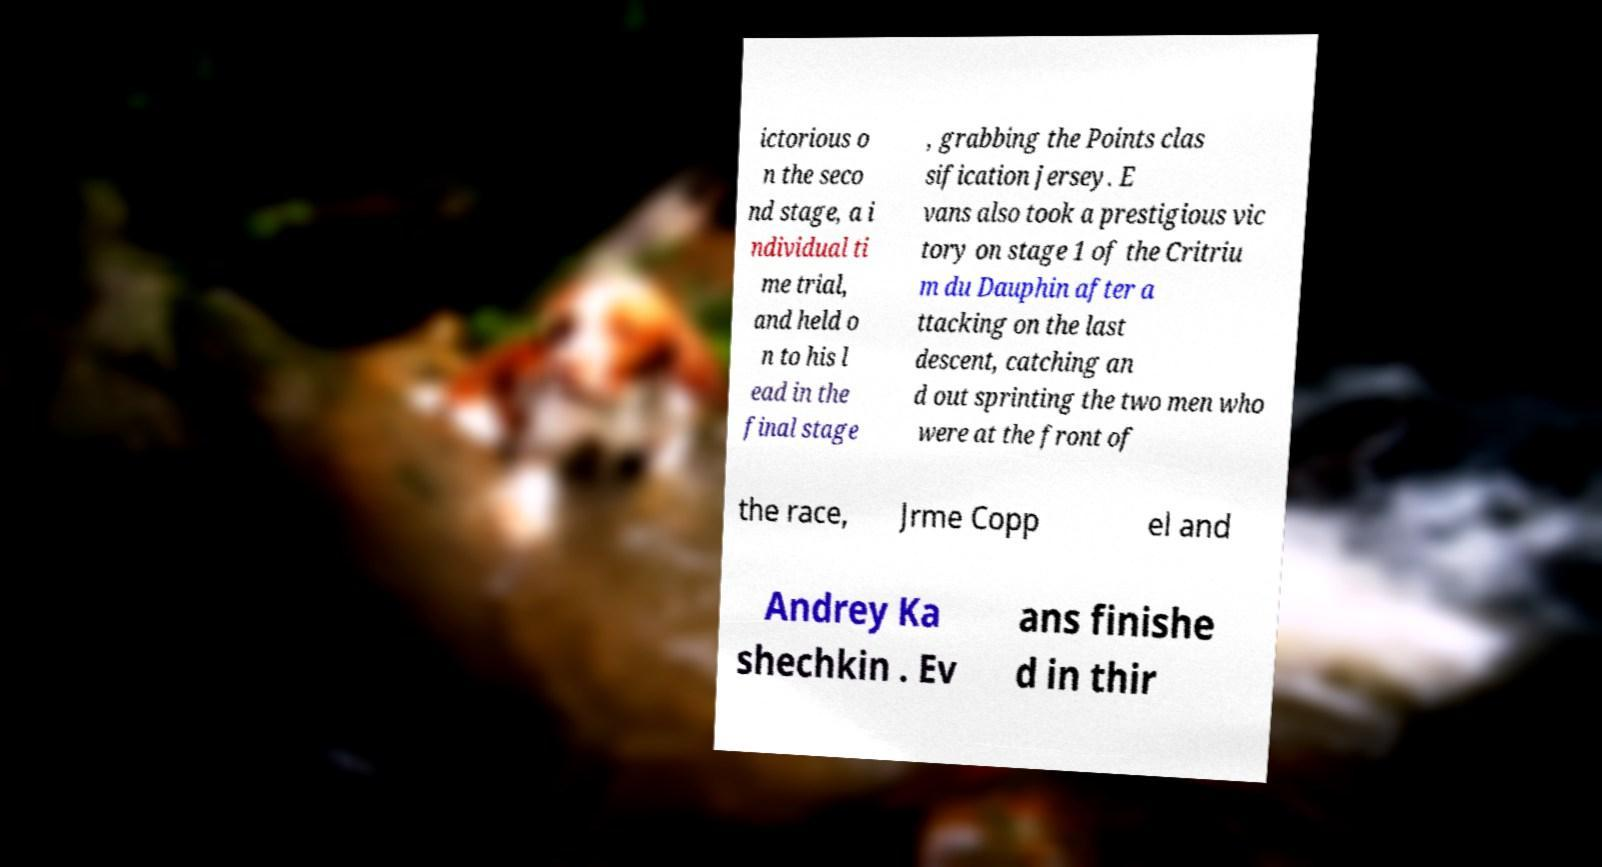Could you assist in decoding the text presented in this image and type it out clearly? ictorious o n the seco nd stage, a i ndividual ti me trial, and held o n to his l ead in the final stage , grabbing the Points clas sification jersey. E vans also took a prestigious vic tory on stage 1 of the Critriu m du Dauphin after a ttacking on the last descent, catching an d out sprinting the two men who were at the front of the race, Jrme Copp el and Andrey Ka shechkin . Ev ans finishe d in thir 